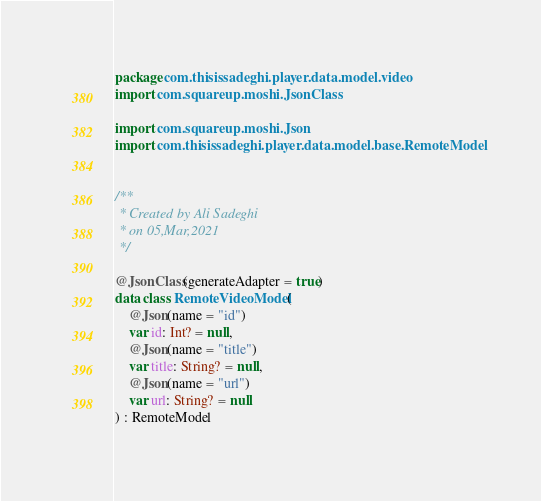<code> <loc_0><loc_0><loc_500><loc_500><_Kotlin_>package com.thisissadeghi.player.data.model.video
import com.squareup.moshi.JsonClass

import com.squareup.moshi.Json
import com.thisissadeghi.player.data.model.base.RemoteModel


/**
 * Created by Ali Sadeghi
 * on 05,Mar,2021
 */

@JsonClass(generateAdapter = true)
data class RemoteVideoModel(
    @Json(name = "id")
    var id: Int? = null,
    @Json(name = "title")
    var title: String? = null,
    @Json(name = "url")
    var url: String? = null
) : RemoteModel
</code> 